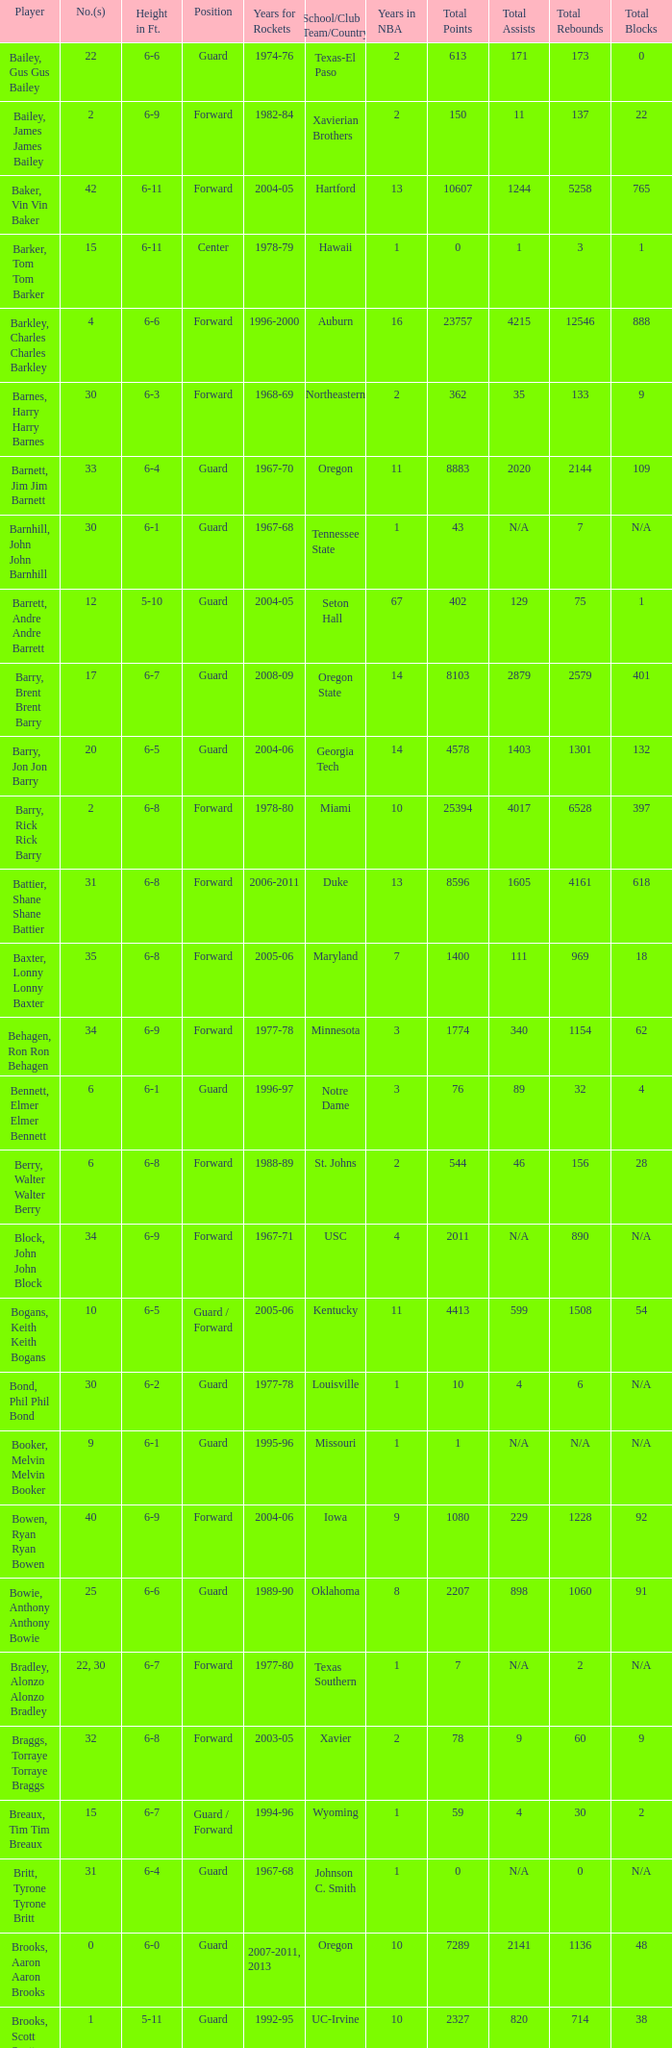What is the height of the player who attended Hartford? 6-11. 